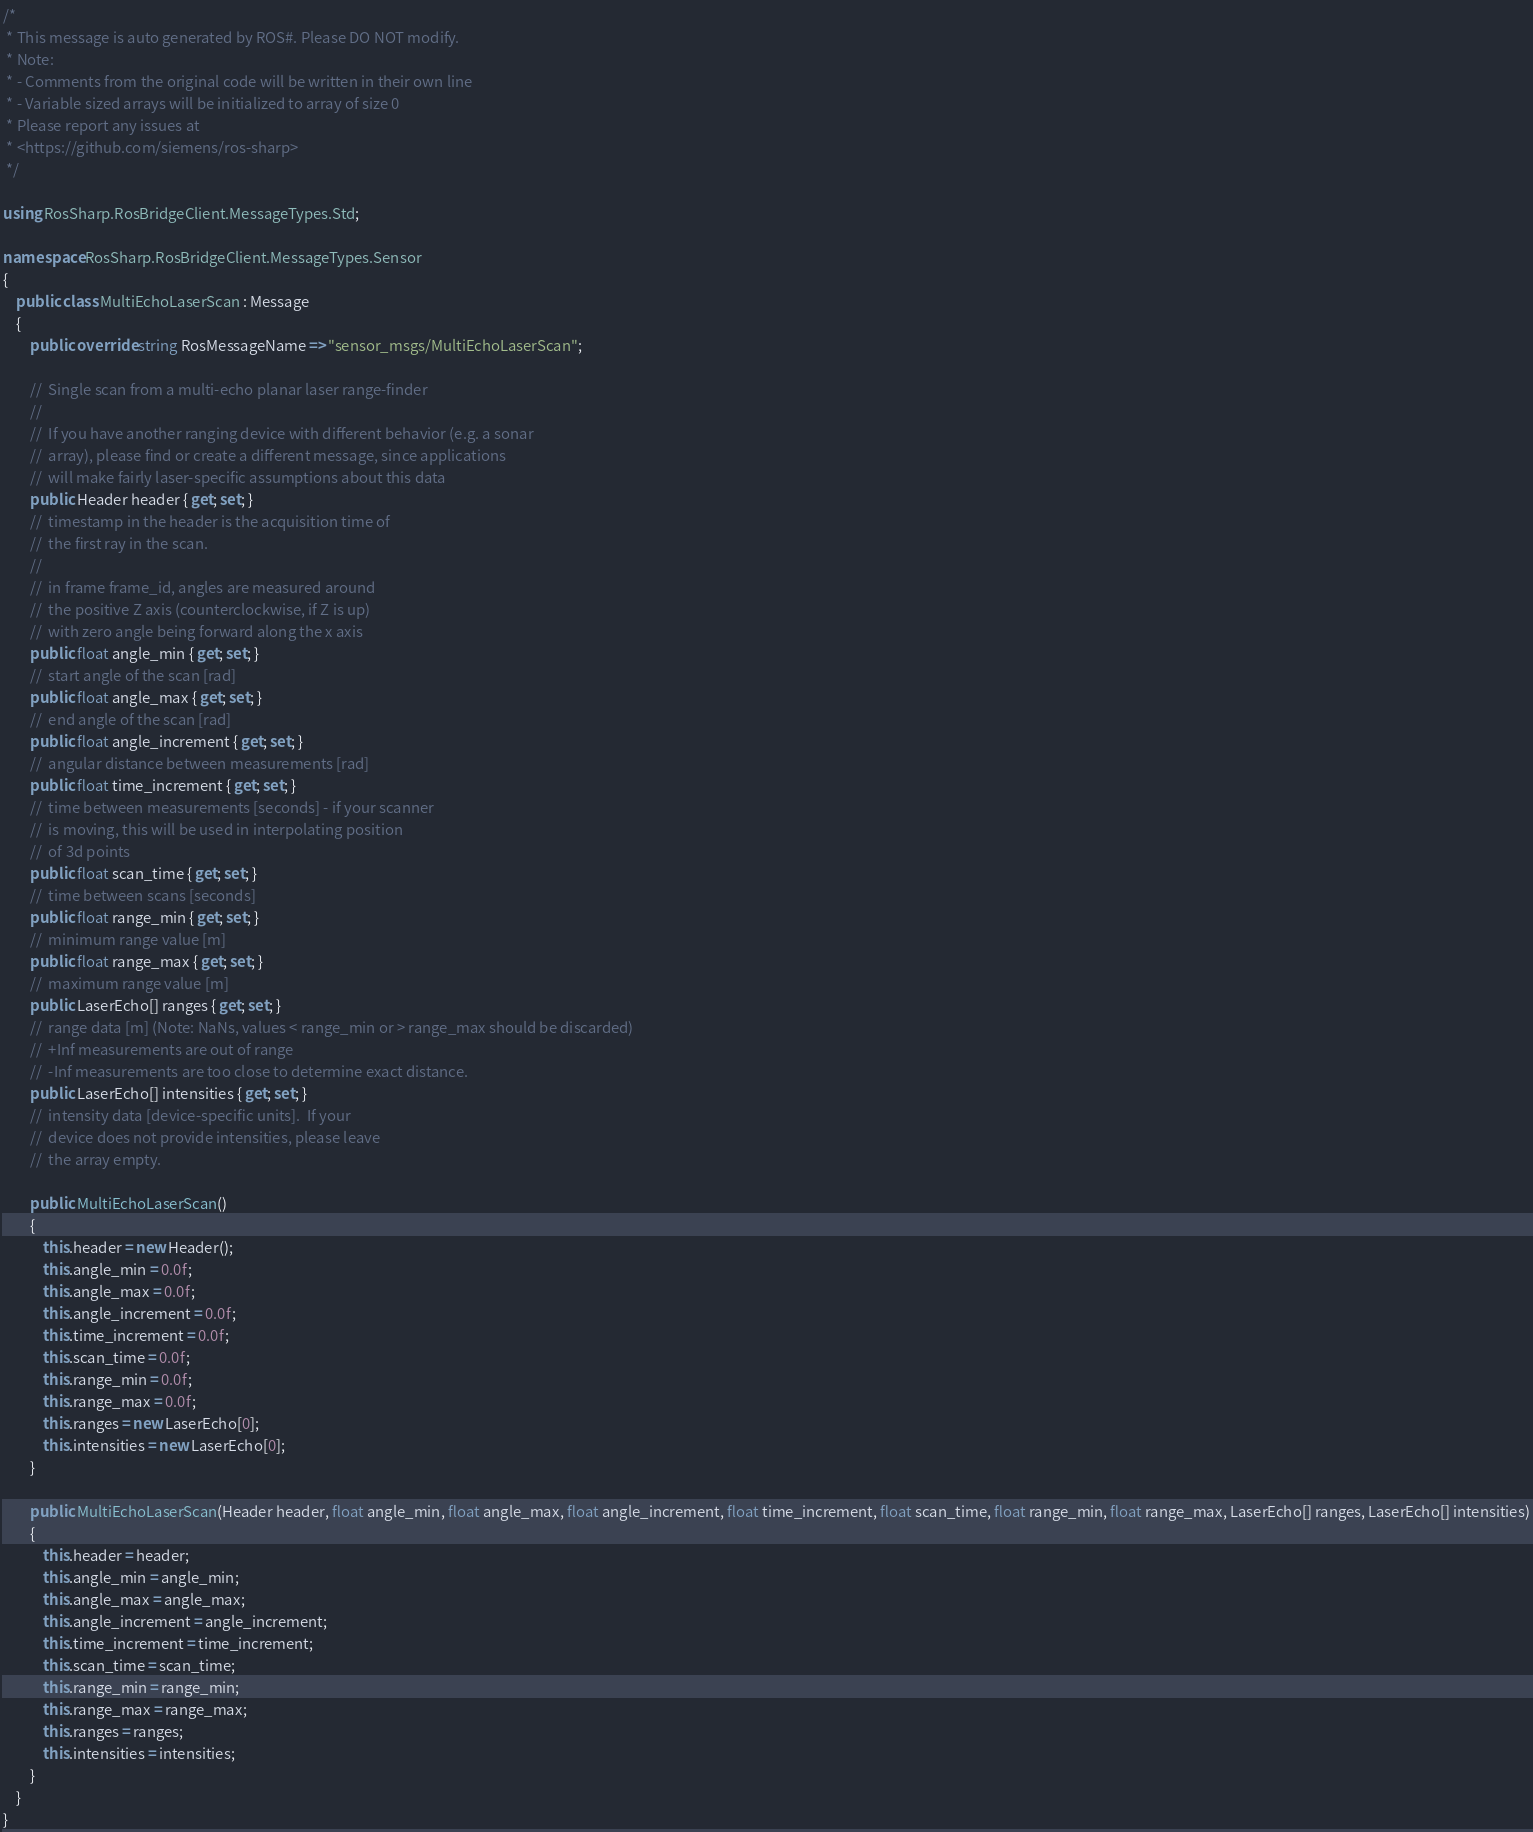<code> <loc_0><loc_0><loc_500><loc_500><_C#_>/* 
 * This message is auto generated by ROS#. Please DO NOT modify.
 * Note:
 * - Comments from the original code will be written in their own line 
 * - Variable sized arrays will be initialized to array of size 0 
 * Please report any issues at 
 * <https://github.com/siemens/ros-sharp> 
 */

using RosSharp.RosBridgeClient.MessageTypes.Std;

namespace RosSharp.RosBridgeClient.MessageTypes.Sensor
{
    public class MultiEchoLaserScan : Message
    {
        public override string RosMessageName => "sensor_msgs/MultiEchoLaserScan";

        //  Single scan from a multi-echo planar laser range-finder
        // 
        //  If you have another ranging device with different behavior (e.g. a sonar
        //  array), please find or create a different message, since applications
        //  will make fairly laser-specific assumptions about this data
        public Header header { get; set; }
        //  timestamp in the header is the acquisition time of 
        //  the first ray in the scan.
        // 
        //  in frame frame_id, angles are measured around 
        //  the positive Z axis (counterclockwise, if Z is up)
        //  with zero angle being forward along the x axis
        public float angle_min { get; set; }
        //  start angle of the scan [rad]
        public float angle_max { get; set; }
        //  end angle of the scan [rad]
        public float angle_increment { get; set; }
        //  angular distance between measurements [rad]
        public float time_increment { get; set; }
        //  time between measurements [seconds] - if your scanner
        //  is moving, this will be used in interpolating position
        //  of 3d points
        public float scan_time { get; set; }
        //  time between scans [seconds]
        public float range_min { get; set; }
        //  minimum range value [m]
        public float range_max { get; set; }
        //  maximum range value [m]
        public LaserEcho[] ranges { get; set; }
        //  range data [m] (Note: NaNs, values < range_min or > range_max should be discarded)
        //  +Inf measurements are out of range
        //  -Inf measurements are too close to determine exact distance.
        public LaserEcho[] intensities { get; set; }
        //  intensity data [device-specific units].  If your
        //  device does not provide intensities, please leave
        //  the array empty.

        public MultiEchoLaserScan()
        {
            this.header = new Header();
            this.angle_min = 0.0f;
            this.angle_max = 0.0f;
            this.angle_increment = 0.0f;
            this.time_increment = 0.0f;
            this.scan_time = 0.0f;
            this.range_min = 0.0f;
            this.range_max = 0.0f;
            this.ranges = new LaserEcho[0];
            this.intensities = new LaserEcho[0];
        }

        public MultiEchoLaserScan(Header header, float angle_min, float angle_max, float angle_increment, float time_increment, float scan_time, float range_min, float range_max, LaserEcho[] ranges, LaserEcho[] intensities)
        {
            this.header = header;
            this.angle_min = angle_min;
            this.angle_max = angle_max;
            this.angle_increment = angle_increment;
            this.time_increment = time_increment;
            this.scan_time = scan_time;
            this.range_min = range_min;
            this.range_max = range_max;
            this.ranges = ranges;
            this.intensities = intensities;
        }
    }
}
</code> 